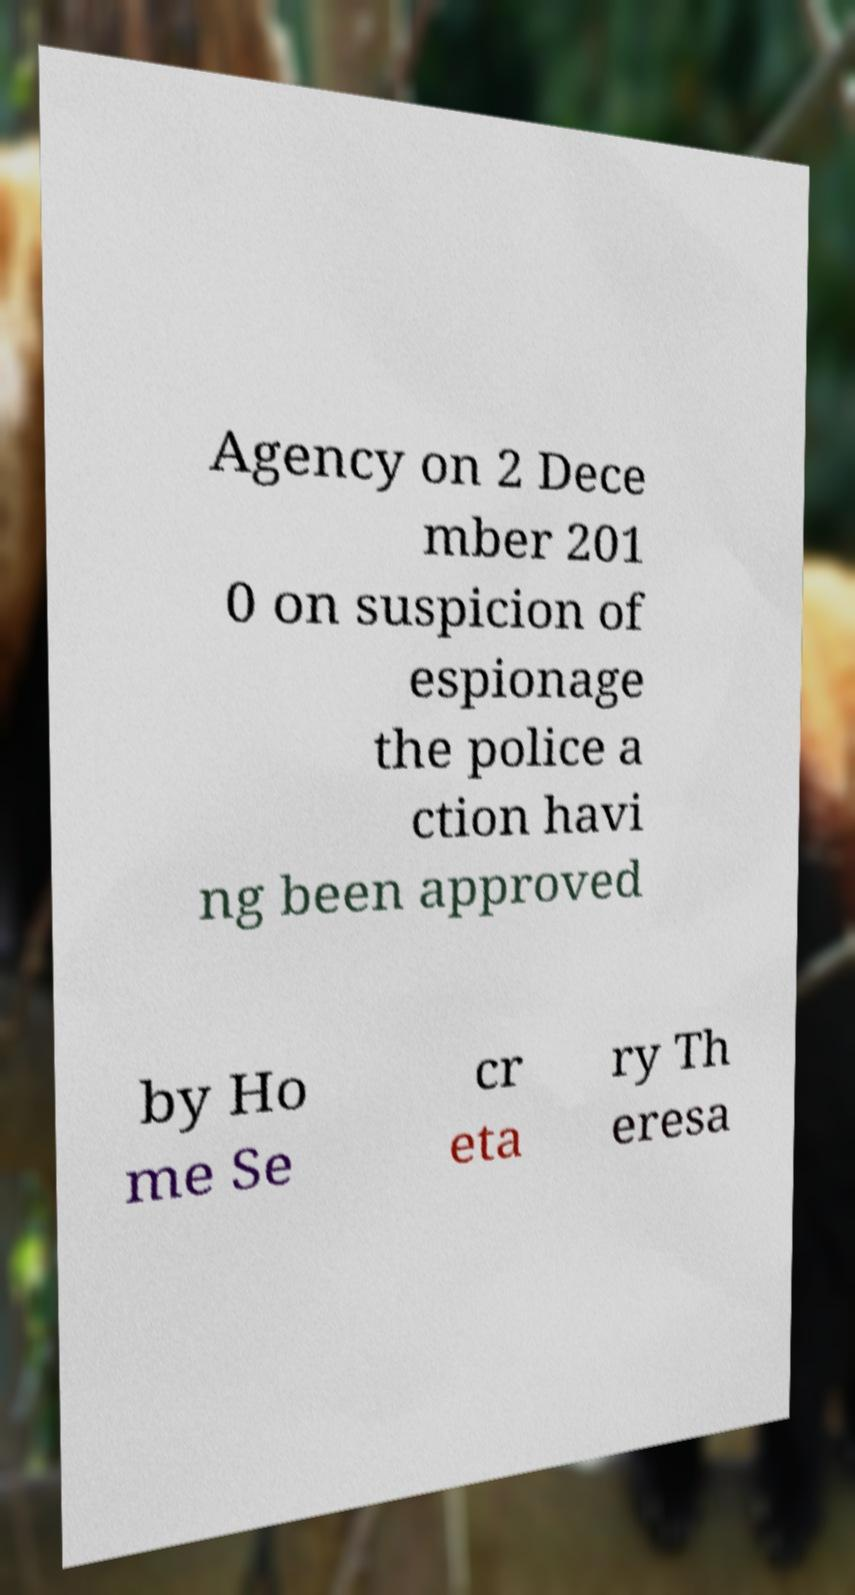Please identify and transcribe the text found in this image. Agency on 2 Dece mber 201 0 on suspicion of espionage the police a ction havi ng been approved by Ho me Se cr eta ry Th eresa 